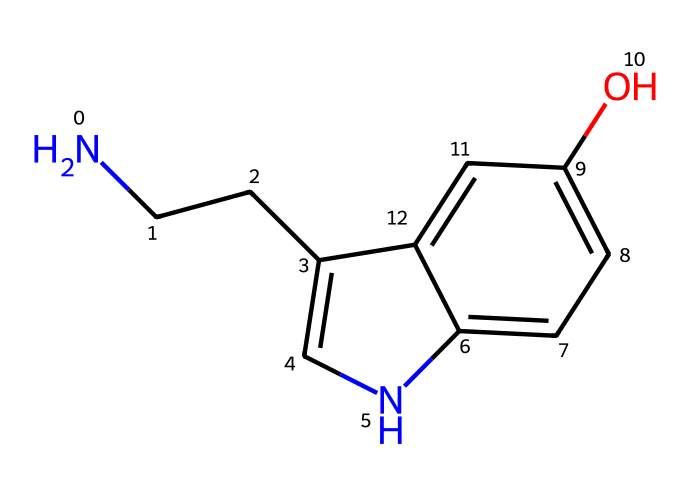What is the molecular formula of serotonin? To find the molecular formula, we parse the SMILES representation for the number of each type of atom. The SMILES shows N (nitrogen), C (carbon), and O (oxygen) atoms. Counting the atoms gives us C10, H12, N2, O1, leading to the molecular formula C10H12N2O.
Answer: C10H12N2O How many rings are present in serotonin? By analyzing the SMILES representation, we can see there are two cycles indicated by the lowercase 'c', which denotes aromatic carbons and the connection points between them. The representation suggests that there are indeed two interconnected rings.
Answer: 2 What type of chemical structure does serotonin represent? Serotonin is categorized as a monoamine neurotransmitter due to its structure, which includes an amine group (NH) and the presence of a monoamine functional group without additional rings.
Answer: monoamine neurotransmitter How many nitrogen atoms are present in serotonin? Examining the SMILES representation reveals two nitrogen atoms based on the "N" present in the structure. Each distinct "N" counts as one nitrogen atom.
Answer: 2 Is serotonin classified as a hormone? Yes, serotonin is often referred to as a hormone-like molecule, as it plays important roles in mood regulation and is released into the bloodstream to exert hormone-like effects throughout the body.
Answer: Yes What functional groups can be identified in serotonin? In the SMILES representation, we can identify an amine group (N) and a hydroxyl group (O as part of -OH) based on the presence of these atoms and their connections in the molecular structure.
Answer: amine and hydroxyl 